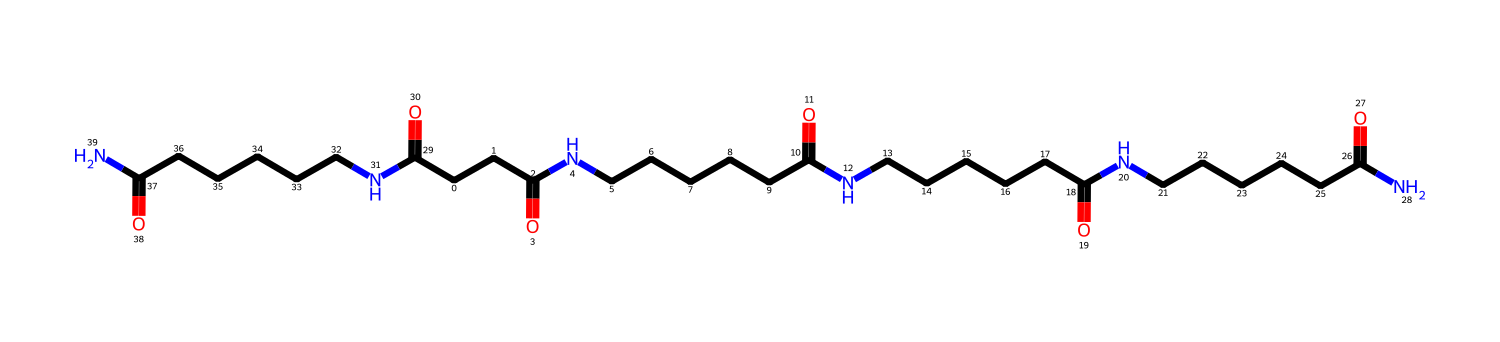What is the main functional group present in nylon? The chemical structure contains amide linkages (–CONH–), which are characteristic of nylon polymers. The presence of nitrogen and carbonyl (C=O) indicates the amide functional group.
Answer: amide How many repeating units of nylon are present? By analyzing the structure, it can be observed that there are multiple occurrences of the basic repeating unit (a unit with an amide bond). There appear to be five repeated units in this SMILES representation of nylon.
Answer: five What is the likely effect of the molecular arrangement on the properties of the fiber? The linear arrangement of the polymer chains allows for strong intermolecular hydrogen bonding due to the functional groups (amide), contributing to high tensile strength and durability, which is important for traditional costume preservation.
Answer: strong In what state would this nylon polymer typically be found at room temperature? Given the structure and properties of nylon, which is known for being a synthetic polymer with high melting points, it is typically found in a solid state at room temperature.
Answer: solid How does the presence of the long carbon chains affect nylon's properties? The long carbon chains contribute to the hydrophobic nature of the fiber and enhance its strength and flexibility, making it suitable for traditional costumes that may need resilience against wear and tear.
Answer: strength and flexibility What type of polymer is represented by this structure? The chemical structure corresponds to a synthetic polyamide, which is commonly known as nylon, indicating that it is made from amide links formed through polycondensation reactions.
Answer: polyamide 